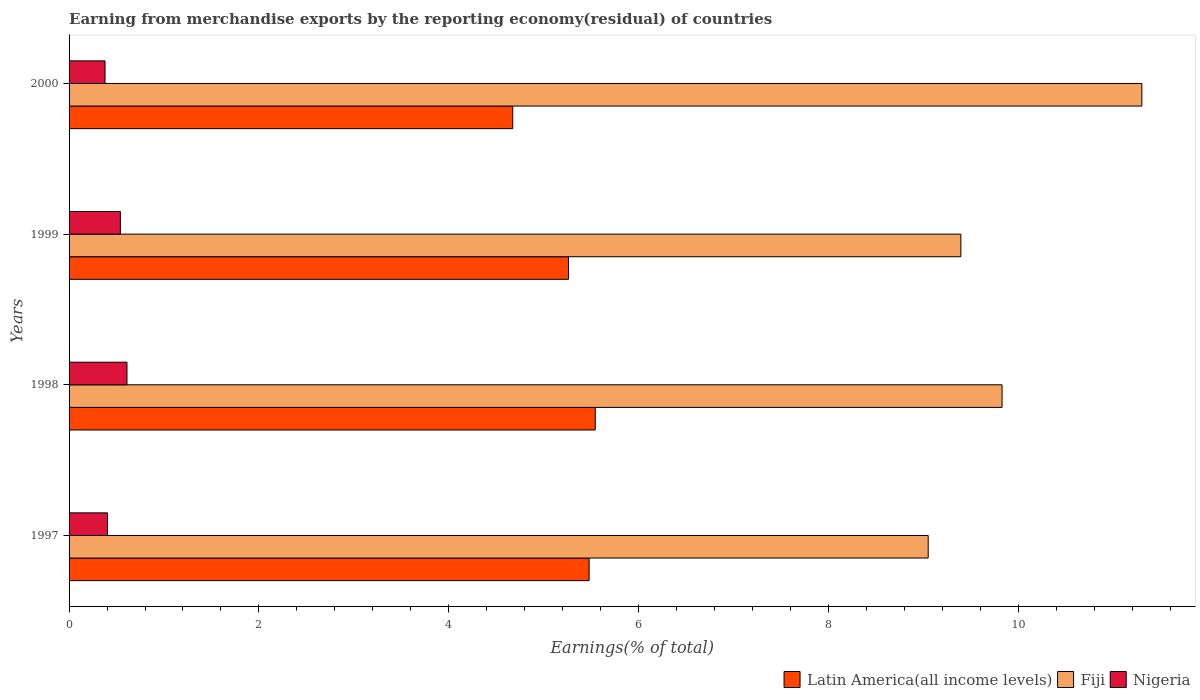How many different coloured bars are there?
Your response must be concise. 3. How many groups of bars are there?
Keep it short and to the point. 4. Are the number of bars per tick equal to the number of legend labels?
Your response must be concise. Yes. What is the percentage of amount earned from merchandise exports in Latin America(all income levels) in 2000?
Your response must be concise. 4.67. Across all years, what is the maximum percentage of amount earned from merchandise exports in Latin America(all income levels)?
Provide a succinct answer. 5.54. Across all years, what is the minimum percentage of amount earned from merchandise exports in Fiji?
Your answer should be compact. 9.05. In which year was the percentage of amount earned from merchandise exports in Nigeria minimum?
Provide a succinct answer. 2000. What is the total percentage of amount earned from merchandise exports in Latin America(all income levels) in the graph?
Offer a terse response. 20.96. What is the difference between the percentage of amount earned from merchandise exports in Fiji in 1998 and that in 1999?
Your answer should be compact. 0.43. What is the difference between the percentage of amount earned from merchandise exports in Fiji in 1997 and the percentage of amount earned from merchandise exports in Latin America(all income levels) in 1999?
Your response must be concise. 3.79. What is the average percentage of amount earned from merchandise exports in Nigeria per year?
Offer a terse response. 0.48. In the year 1999, what is the difference between the percentage of amount earned from merchandise exports in Latin America(all income levels) and percentage of amount earned from merchandise exports in Nigeria?
Your answer should be very brief. 4.72. What is the ratio of the percentage of amount earned from merchandise exports in Nigeria in 1998 to that in 2000?
Your answer should be very brief. 1.61. Is the percentage of amount earned from merchandise exports in Latin America(all income levels) in 1999 less than that in 2000?
Ensure brevity in your answer.  No. Is the difference between the percentage of amount earned from merchandise exports in Latin America(all income levels) in 1999 and 2000 greater than the difference between the percentage of amount earned from merchandise exports in Nigeria in 1999 and 2000?
Offer a terse response. Yes. What is the difference between the highest and the second highest percentage of amount earned from merchandise exports in Nigeria?
Ensure brevity in your answer.  0.07. What is the difference between the highest and the lowest percentage of amount earned from merchandise exports in Latin America(all income levels)?
Make the answer very short. 0.87. In how many years, is the percentage of amount earned from merchandise exports in Fiji greater than the average percentage of amount earned from merchandise exports in Fiji taken over all years?
Provide a succinct answer. 1. Is the sum of the percentage of amount earned from merchandise exports in Nigeria in 1998 and 2000 greater than the maximum percentage of amount earned from merchandise exports in Fiji across all years?
Provide a succinct answer. No. What does the 3rd bar from the top in 1999 represents?
Your answer should be very brief. Latin America(all income levels). What does the 3rd bar from the bottom in 2000 represents?
Provide a short and direct response. Nigeria. Does the graph contain grids?
Provide a short and direct response. No. How many legend labels are there?
Offer a terse response. 3. What is the title of the graph?
Provide a short and direct response. Earning from merchandise exports by the reporting economy(residual) of countries. What is the label or title of the X-axis?
Give a very brief answer. Earnings(% of total). What is the label or title of the Y-axis?
Offer a very short reply. Years. What is the Earnings(% of total) of Latin America(all income levels) in 1997?
Provide a short and direct response. 5.48. What is the Earnings(% of total) of Fiji in 1997?
Your answer should be very brief. 9.05. What is the Earnings(% of total) of Nigeria in 1997?
Your answer should be compact. 0.4. What is the Earnings(% of total) in Latin America(all income levels) in 1998?
Offer a terse response. 5.54. What is the Earnings(% of total) of Fiji in 1998?
Provide a succinct answer. 9.83. What is the Earnings(% of total) of Nigeria in 1998?
Provide a short and direct response. 0.61. What is the Earnings(% of total) in Latin America(all income levels) in 1999?
Ensure brevity in your answer.  5.26. What is the Earnings(% of total) in Fiji in 1999?
Make the answer very short. 9.4. What is the Earnings(% of total) of Nigeria in 1999?
Ensure brevity in your answer.  0.54. What is the Earnings(% of total) in Latin America(all income levels) in 2000?
Make the answer very short. 4.67. What is the Earnings(% of total) of Fiji in 2000?
Offer a terse response. 11.3. What is the Earnings(% of total) in Nigeria in 2000?
Offer a very short reply. 0.38. Across all years, what is the maximum Earnings(% of total) of Latin America(all income levels)?
Ensure brevity in your answer.  5.54. Across all years, what is the maximum Earnings(% of total) in Fiji?
Your answer should be compact. 11.3. Across all years, what is the maximum Earnings(% of total) of Nigeria?
Your answer should be compact. 0.61. Across all years, what is the minimum Earnings(% of total) in Latin America(all income levels)?
Your answer should be compact. 4.67. Across all years, what is the minimum Earnings(% of total) of Fiji?
Offer a very short reply. 9.05. Across all years, what is the minimum Earnings(% of total) in Nigeria?
Provide a succinct answer. 0.38. What is the total Earnings(% of total) of Latin America(all income levels) in the graph?
Provide a short and direct response. 20.96. What is the total Earnings(% of total) in Fiji in the graph?
Your answer should be compact. 39.58. What is the total Earnings(% of total) in Nigeria in the graph?
Provide a succinct answer. 1.93. What is the difference between the Earnings(% of total) of Latin America(all income levels) in 1997 and that in 1998?
Offer a very short reply. -0.06. What is the difference between the Earnings(% of total) in Fiji in 1997 and that in 1998?
Provide a short and direct response. -0.78. What is the difference between the Earnings(% of total) of Nigeria in 1997 and that in 1998?
Provide a short and direct response. -0.21. What is the difference between the Earnings(% of total) of Latin America(all income levels) in 1997 and that in 1999?
Give a very brief answer. 0.22. What is the difference between the Earnings(% of total) in Fiji in 1997 and that in 1999?
Offer a terse response. -0.34. What is the difference between the Earnings(% of total) of Nigeria in 1997 and that in 1999?
Keep it short and to the point. -0.14. What is the difference between the Earnings(% of total) in Latin America(all income levels) in 1997 and that in 2000?
Keep it short and to the point. 0.81. What is the difference between the Earnings(% of total) of Fiji in 1997 and that in 2000?
Provide a succinct answer. -2.25. What is the difference between the Earnings(% of total) in Nigeria in 1997 and that in 2000?
Offer a terse response. 0.03. What is the difference between the Earnings(% of total) in Latin America(all income levels) in 1998 and that in 1999?
Provide a short and direct response. 0.28. What is the difference between the Earnings(% of total) of Fiji in 1998 and that in 1999?
Provide a succinct answer. 0.43. What is the difference between the Earnings(% of total) of Nigeria in 1998 and that in 1999?
Give a very brief answer. 0.07. What is the difference between the Earnings(% of total) of Latin America(all income levels) in 1998 and that in 2000?
Keep it short and to the point. 0.87. What is the difference between the Earnings(% of total) of Fiji in 1998 and that in 2000?
Your answer should be very brief. -1.47. What is the difference between the Earnings(% of total) in Nigeria in 1998 and that in 2000?
Give a very brief answer. 0.23. What is the difference between the Earnings(% of total) in Latin America(all income levels) in 1999 and that in 2000?
Ensure brevity in your answer.  0.59. What is the difference between the Earnings(% of total) of Fiji in 1999 and that in 2000?
Your response must be concise. -1.91. What is the difference between the Earnings(% of total) of Nigeria in 1999 and that in 2000?
Provide a succinct answer. 0.16. What is the difference between the Earnings(% of total) in Latin America(all income levels) in 1997 and the Earnings(% of total) in Fiji in 1998?
Provide a succinct answer. -4.35. What is the difference between the Earnings(% of total) of Latin America(all income levels) in 1997 and the Earnings(% of total) of Nigeria in 1998?
Your response must be concise. 4.87. What is the difference between the Earnings(% of total) in Fiji in 1997 and the Earnings(% of total) in Nigeria in 1998?
Make the answer very short. 8.44. What is the difference between the Earnings(% of total) of Latin America(all income levels) in 1997 and the Earnings(% of total) of Fiji in 1999?
Your answer should be compact. -3.92. What is the difference between the Earnings(% of total) of Latin America(all income levels) in 1997 and the Earnings(% of total) of Nigeria in 1999?
Keep it short and to the point. 4.94. What is the difference between the Earnings(% of total) in Fiji in 1997 and the Earnings(% of total) in Nigeria in 1999?
Your answer should be compact. 8.51. What is the difference between the Earnings(% of total) in Latin America(all income levels) in 1997 and the Earnings(% of total) in Fiji in 2000?
Ensure brevity in your answer.  -5.82. What is the difference between the Earnings(% of total) of Latin America(all income levels) in 1997 and the Earnings(% of total) of Nigeria in 2000?
Keep it short and to the point. 5.1. What is the difference between the Earnings(% of total) in Fiji in 1997 and the Earnings(% of total) in Nigeria in 2000?
Your answer should be compact. 8.67. What is the difference between the Earnings(% of total) in Latin America(all income levels) in 1998 and the Earnings(% of total) in Fiji in 1999?
Make the answer very short. -3.85. What is the difference between the Earnings(% of total) of Latin America(all income levels) in 1998 and the Earnings(% of total) of Nigeria in 1999?
Make the answer very short. 5. What is the difference between the Earnings(% of total) in Fiji in 1998 and the Earnings(% of total) in Nigeria in 1999?
Your response must be concise. 9.29. What is the difference between the Earnings(% of total) in Latin America(all income levels) in 1998 and the Earnings(% of total) in Fiji in 2000?
Give a very brief answer. -5.76. What is the difference between the Earnings(% of total) of Latin America(all income levels) in 1998 and the Earnings(% of total) of Nigeria in 2000?
Your answer should be very brief. 5.17. What is the difference between the Earnings(% of total) in Fiji in 1998 and the Earnings(% of total) in Nigeria in 2000?
Make the answer very short. 9.45. What is the difference between the Earnings(% of total) in Latin America(all income levels) in 1999 and the Earnings(% of total) in Fiji in 2000?
Offer a terse response. -6.04. What is the difference between the Earnings(% of total) in Latin America(all income levels) in 1999 and the Earnings(% of total) in Nigeria in 2000?
Keep it short and to the point. 4.88. What is the difference between the Earnings(% of total) in Fiji in 1999 and the Earnings(% of total) in Nigeria in 2000?
Your response must be concise. 9.02. What is the average Earnings(% of total) in Latin America(all income levels) per year?
Provide a short and direct response. 5.24. What is the average Earnings(% of total) in Fiji per year?
Offer a terse response. 9.9. What is the average Earnings(% of total) in Nigeria per year?
Ensure brevity in your answer.  0.48. In the year 1997, what is the difference between the Earnings(% of total) of Latin America(all income levels) and Earnings(% of total) of Fiji?
Your answer should be compact. -3.57. In the year 1997, what is the difference between the Earnings(% of total) in Latin America(all income levels) and Earnings(% of total) in Nigeria?
Offer a very short reply. 5.07. In the year 1997, what is the difference between the Earnings(% of total) in Fiji and Earnings(% of total) in Nigeria?
Offer a very short reply. 8.65. In the year 1998, what is the difference between the Earnings(% of total) of Latin America(all income levels) and Earnings(% of total) of Fiji?
Your answer should be very brief. -4.29. In the year 1998, what is the difference between the Earnings(% of total) in Latin America(all income levels) and Earnings(% of total) in Nigeria?
Offer a very short reply. 4.93. In the year 1998, what is the difference between the Earnings(% of total) in Fiji and Earnings(% of total) in Nigeria?
Your response must be concise. 9.22. In the year 1999, what is the difference between the Earnings(% of total) in Latin America(all income levels) and Earnings(% of total) in Fiji?
Your answer should be very brief. -4.13. In the year 1999, what is the difference between the Earnings(% of total) of Latin America(all income levels) and Earnings(% of total) of Nigeria?
Make the answer very short. 4.72. In the year 1999, what is the difference between the Earnings(% of total) of Fiji and Earnings(% of total) of Nigeria?
Your answer should be compact. 8.86. In the year 2000, what is the difference between the Earnings(% of total) of Latin America(all income levels) and Earnings(% of total) of Fiji?
Keep it short and to the point. -6.63. In the year 2000, what is the difference between the Earnings(% of total) of Latin America(all income levels) and Earnings(% of total) of Nigeria?
Give a very brief answer. 4.3. In the year 2000, what is the difference between the Earnings(% of total) in Fiji and Earnings(% of total) in Nigeria?
Keep it short and to the point. 10.92. What is the ratio of the Earnings(% of total) of Latin America(all income levels) in 1997 to that in 1998?
Provide a short and direct response. 0.99. What is the ratio of the Earnings(% of total) of Fiji in 1997 to that in 1998?
Keep it short and to the point. 0.92. What is the ratio of the Earnings(% of total) in Nigeria in 1997 to that in 1998?
Give a very brief answer. 0.66. What is the ratio of the Earnings(% of total) in Latin America(all income levels) in 1997 to that in 1999?
Give a very brief answer. 1.04. What is the ratio of the Earnings(% of total) of Fiji in 1997 to that in 1999?
Your response must be concise. 0.96. What is the ratio of the Earnings(% of total) in Nigeria in 1997 to that in 1999?
Offer a terse response. 0.75. What is the ratio of the Earnings(% of total) of Latin America(all income levels) in 1997 to that in 2000?
Offer a very short reply. 1.17. What is the ratio of the Earnings(% of total) in Fiji in 1997 to that in 2000?
Your answer should be very brief. 0.8. What is the ratio of the Earnings(% of total) of Nigeria in 1997 to that in 2000?
Offer a very short reply. 1.07. What is the ratio of the Earnings(% of total) of Latin America(all income levels) in 1998 to that in 1999?
Offer a terse response. 1.05. What is the ratio of the Earnings(% of total) of Fiji in 1998 to that in 1999?
Offer a very short reply. 1.05. What is the ratio of the Earnings(% of total) in Nigeria in 1998 to that in 1999?
Offer a very short reply. 1.13. What is the ratio of the Earnings(% of total) in Latin America(all income levels) in 1998 to that in 2000?
Make the answer very short. 1.19. What is the ratio of the Earnings(% of total) in Fiji in 1998 to that in 2000?
Make the answer very short. 0.87. What is the ratio of the Earnings(% of total) in Nigeria in 1998 to that in 2000?
Your answer should be very brief. 1.61. What is the ratio of the Earnings(% of total) in Latin America(all income levels) in 1999 to that in 2000?
Give a very brief answer. 1.13. What is the ratio of the Earnings(% of total) in Fiji in 1999 to that in 2000?
Your answer should be compact. 0.83. What is the ratio of the Earnings(% of total) in Nigeria in 1999 to that in 2000?
Your response must be concise. 1.43. What is the difference between the highest and the second highest Earnings(% of total) in Latin America(all income levels)?
Your answer should be very brief. 0.06. What is the difference between the highest and the second highest Earnings(% of total) of Fiji?
Offer a very short reply. 1.47. What is the difference between the highest and the second highest Earnings(% of total) in Nigeria?
Your response must be concise. 0.07. What is the difference between the highest and the lowest Earnings(% of total) in Latin America(all income levels)?
Your answer should be compact. 0.87. What is the difference between the highest and the lowest Earnings(% of total) in Fiji?
Offer a very short reply. 2.25. What is the difference between the highest and the lowest Earnings(% of total) in Nigeria?
Offer a very short reply. 0.23. 